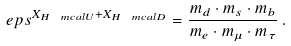Convert formula to latex. <formula><loc_0><loc_0><loc_500><loc_500>\ e p s ^ { X _ { H ^ { \ } m c a l { U } } + X _ { H ^ { \ } m c a l { D } } } = \frac { m _ { d } \cdot m _ { s } \cdot m _ { b } } { m _ { e } \cdot m _ { \mu } \cdot m _ { \tau } } \, .</formula> 